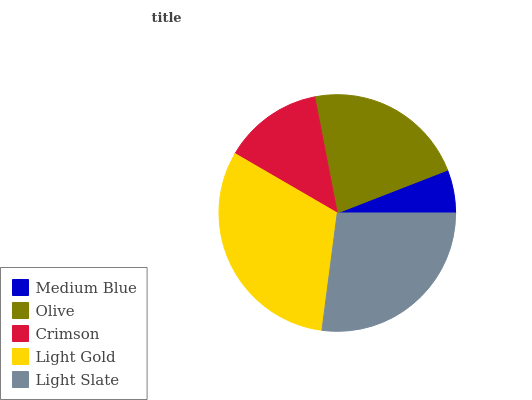Is Medium Blue the minimum?
Answer yes or no. Yes. Is Light Gold the maximum?
Answer yes or no. Yes. Is Olive the minimum?
Answer yes or no. No. Is Olive the maximum?
Answer yes or no. No. Is Olive greater than Medium Blue?
Answer yes or no. Yes. Is Medium Blue less than Olive?
Answer yes or no. Yes. Is Medium Blue greater than Olive?
Answer yes or no. No. Is Olive less than Medium Blue?
Answer yes or no. No. Is Olive the high median?
Answer yes or no. Yes. Is Olive the low median?
Answer yes or no. Yes. Is Medium Blue the high median?
Answer yes or no. No. Is Medium Blue the low median?
Answer yes or no. No. 